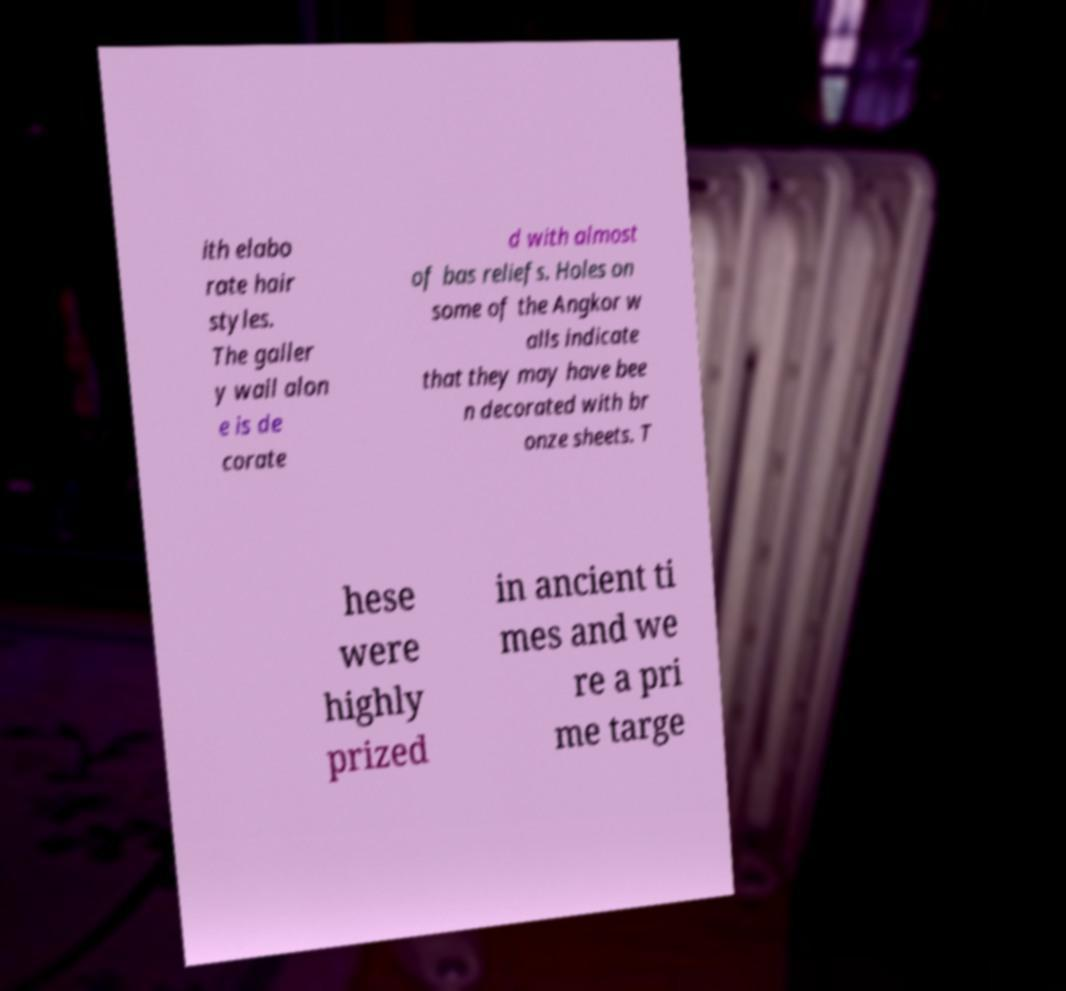For documentation purposes, I need the text within this image transcribed. Could you provide that? ith elabo rate hair styles. The galler y wall alon e is de corate d with almost of bas reliefs. Holes on some of the Angkor w alls indicate that they may have bee n decorated with br onze sheets. T hese were highly prized in ancient ti mes and we re a pri me targe 